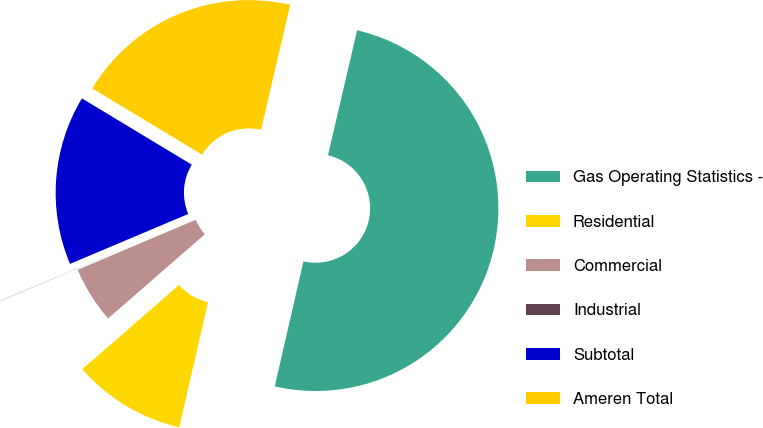Convert chart to OTSL. <chart><loc_0><loc_0><loc_500><loc_500><pie_chart><fcel>Gas Operating Statistics -<fcel>Residential<fcel>Commercial<fcel>Industrial<fcel>Subtotal<fcel>Ameren Total<nl><fcel>49.95%<fcel>10.01%<fcel>5.02%<fcel>0.02%<fcel>15.0%<fcel>20.0%<nl></chart> 